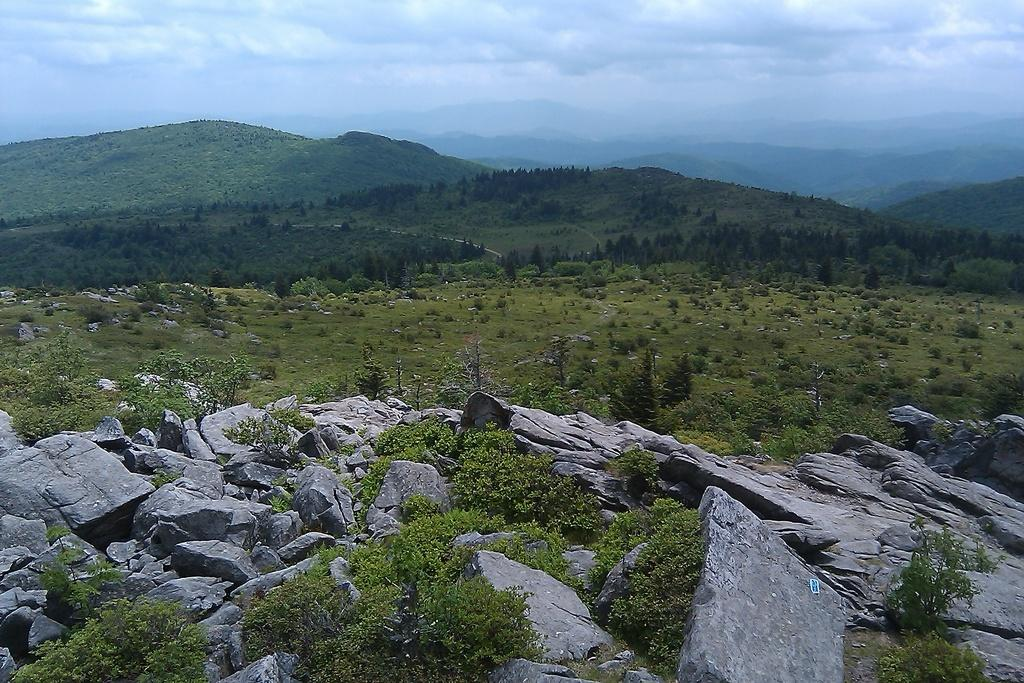What type of ground cover can be seen in the image? There are stones and grass on the ground in the image. What can be seen in the background of the image? There are trees, mountains, and the sky visible in the background of the image. Are there any shoes hanging from the trees in the image? There are no shoes visible in the image; only stones, grass, trees, mountains, and the sky are present. Can you see a man walking through the grass in the image? There is no man present in the image; only stones, grass, trees, mountains, and the sky are visible. 